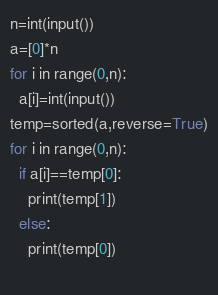Convert code to text. <code><loc_0><loc_0><loc_500><loc_500><_Python_>n=int(input())
a=[0]*n
for i in range(0,n):
  a[i]=int(input())
temp=sorted(a,reverse=True)
for i in range(0,n):
  if a[i]==temp[0]:
    print(temp[1])
  else:
    print(temp[0])
        </code> 